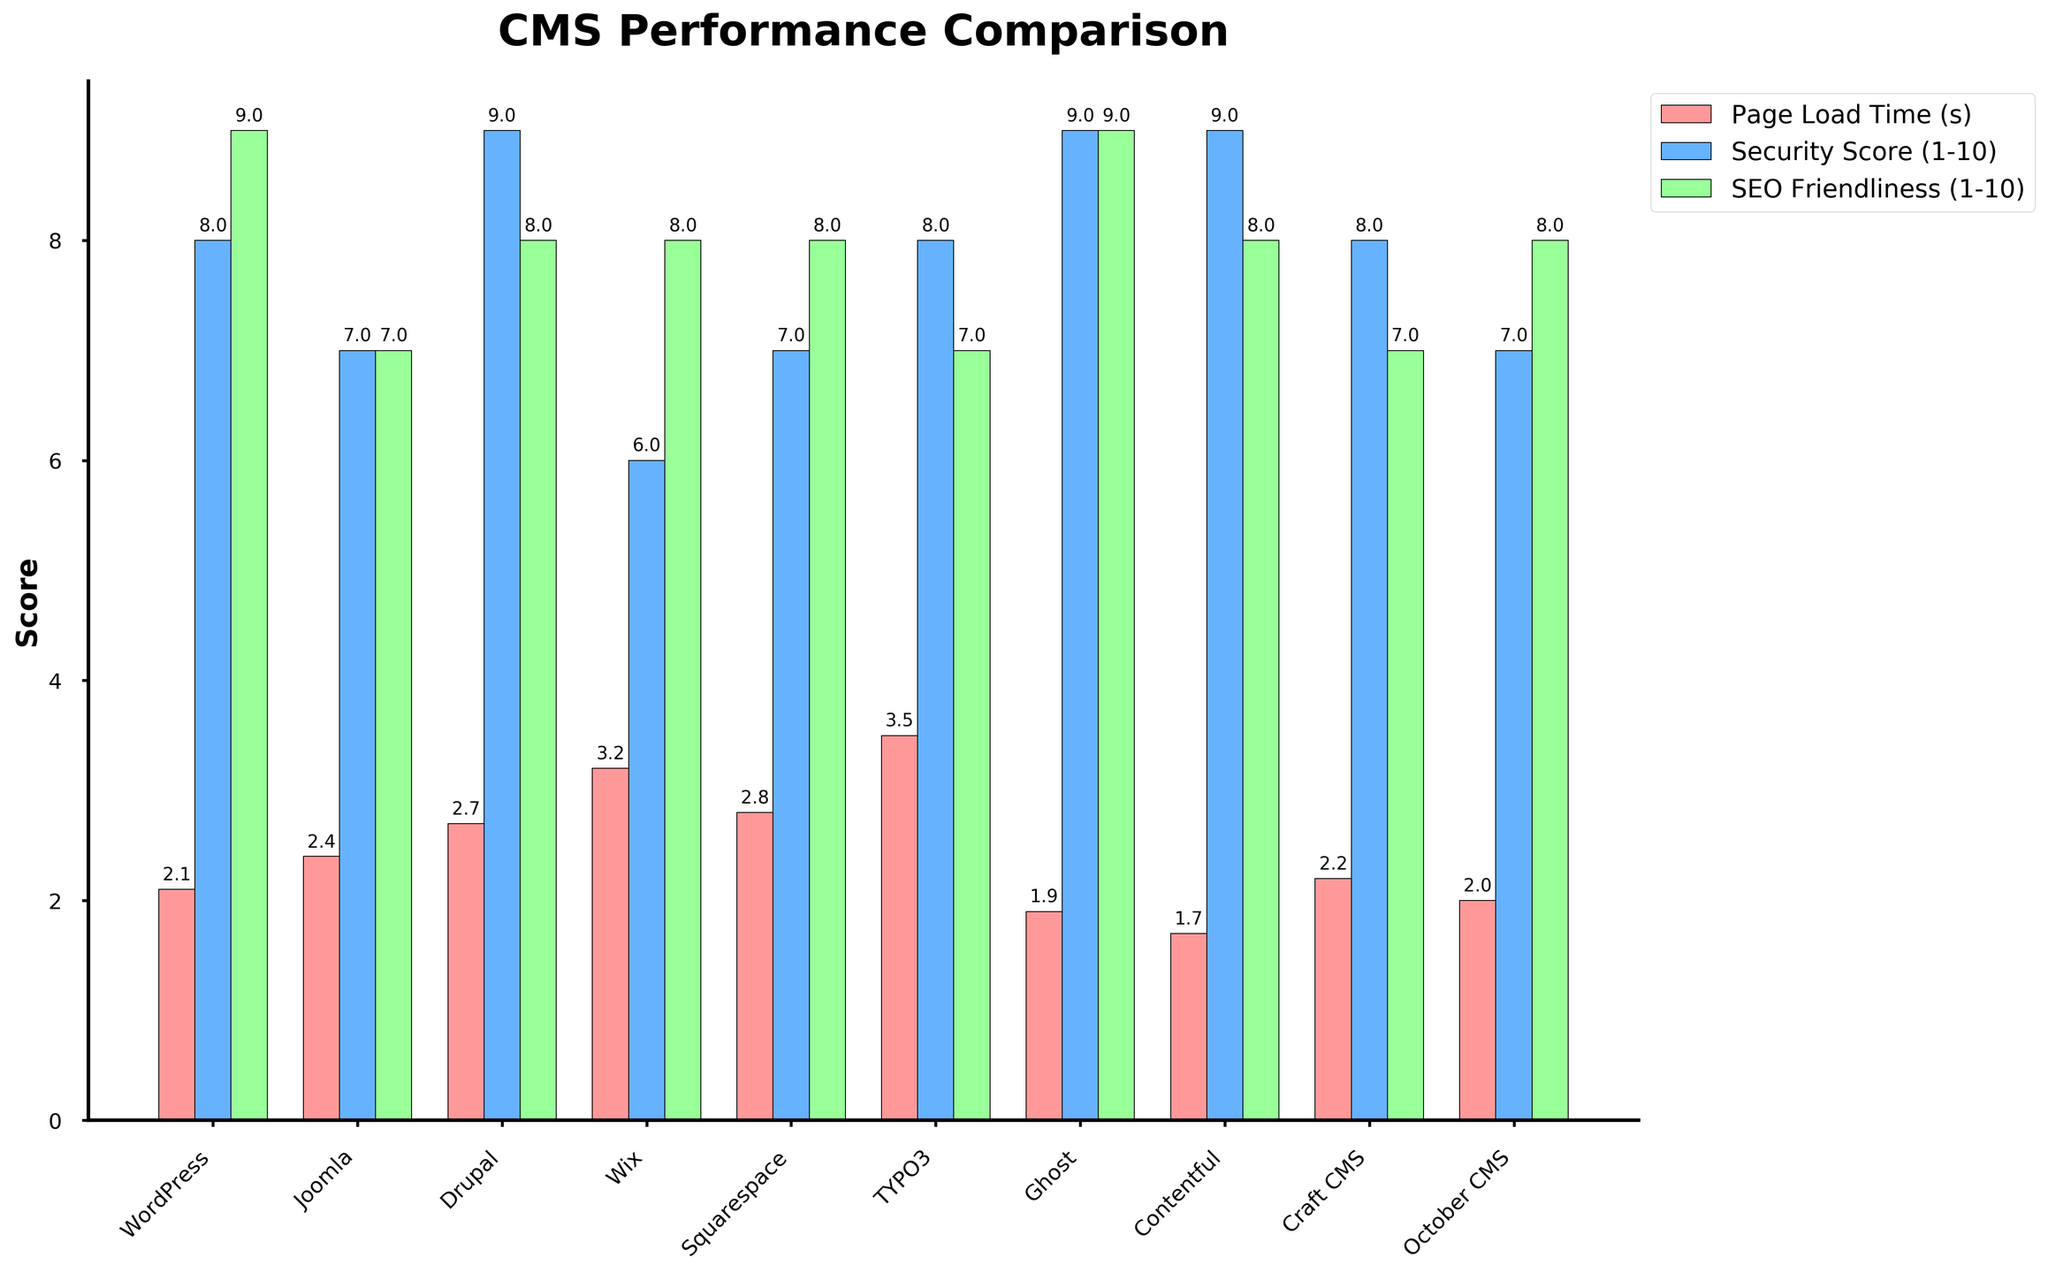How does the Page Load Time of Contentful compare to WordPress? To compare the Page Load Time of Contentful with WordPress, look at the heights of the bars for "Page Load Time (s)" for both CMS. Contentful's bar is shorter than WordPress's bar, indicating a shorter page load time.
Answer: Contentful has a shorter page load time than WordPress Which CMS has the highest Security Score, and what is it? To find the CMS with the highest Security Score, look for the tallest blue bar under the "Security Score (1-10)" metric. Drupal, Contentful, and Ghost all have the highest bar at a Security Score of 9.
Answer: Drupal, Contentful, and Ghost with a Security Score of 9 What is the difference in SEO Friendliness between Joomla and Wix? To compare SEO Friendliness between Joomla and Wix, look at the heights of the green bars for both CMS. Both Joomla and Wix have green bars reaching the same height, indicating they have the same SEO Friendliness score.
Answer: 0 (They have the same SEO Friendliness score of 8) Which CMS has the lowest Page Load Time, and what is its value? The CMS with the lowest Page Load Time will have the shortest red bar under the "Page Load Time (s)" metric. Ghost has the shortest red bar, indicating the lowest Page Load Time.
Answer: Ghost with a Page Load Time of 1.9 seconds What is the average Security Score of WordPress, Joomla, and Drupal? To calculate the average Security Score, look at the blue bars for WordPress, Joomla, and Drupal. The scores are 8, 7, and 9 respectively. The average is (8 + 7 + 9) / 3 = 24 / 3.
Answer: 8 Which CMS has the highest overall performance based on the Security Score and SEO Friendliness? Consider both the Security Score and SEO Friendliness. Ghost and Contentful both have high scores in both metrics (Security Score of 9 and SEO Friendliness of 9 and 8 respectively). Ghost has slightly higher average score.
Answer: Ghost What is the sum of the Security Score and Page Load Time for Wix? Add the values of the blue and red bars for Wix. The Security Score is 6, and the Page Load Time is 3.2 seconds. The sum is 6 + 3.2.
Answer: 9.2 Which CMS has a better performance in terms of both lower Page Load Time and higher SEO Friendliness: Craft CMS or October CMS? Compare the red and green bars of Craft CMS and October CMS. Craft CMS has a Page Load Time of 2.2s and SEO Friendliness of 7. October CMS has a Page Load Time of 2.0s and SEO Friendliness of 8. October CMS has a slightly lower page load time but higher SEO Friendliness.
Answer: October CMS How much higher is the Security Score of Typo3 compared to Wix? Look at the blue bars for both Typo3 and Wix. Typo3 has a Security Score of 8, and Wix has a Security Score of 6. The difference is 8 - 6.
Answer: 2 Which CMS stands out the most visually in terms of the heights of the bars in any of the metrics? Identify the CMS with the significantly tallest or shortest bar compared to others in any metric. Wix stands out with the tallest bar in the "Monthly Active Users (millions)" category, but there is no bar for this in the given chart. However, visually, Ghost stands out with very low Page Load Time and high Security Score.
Answer: Ghost 